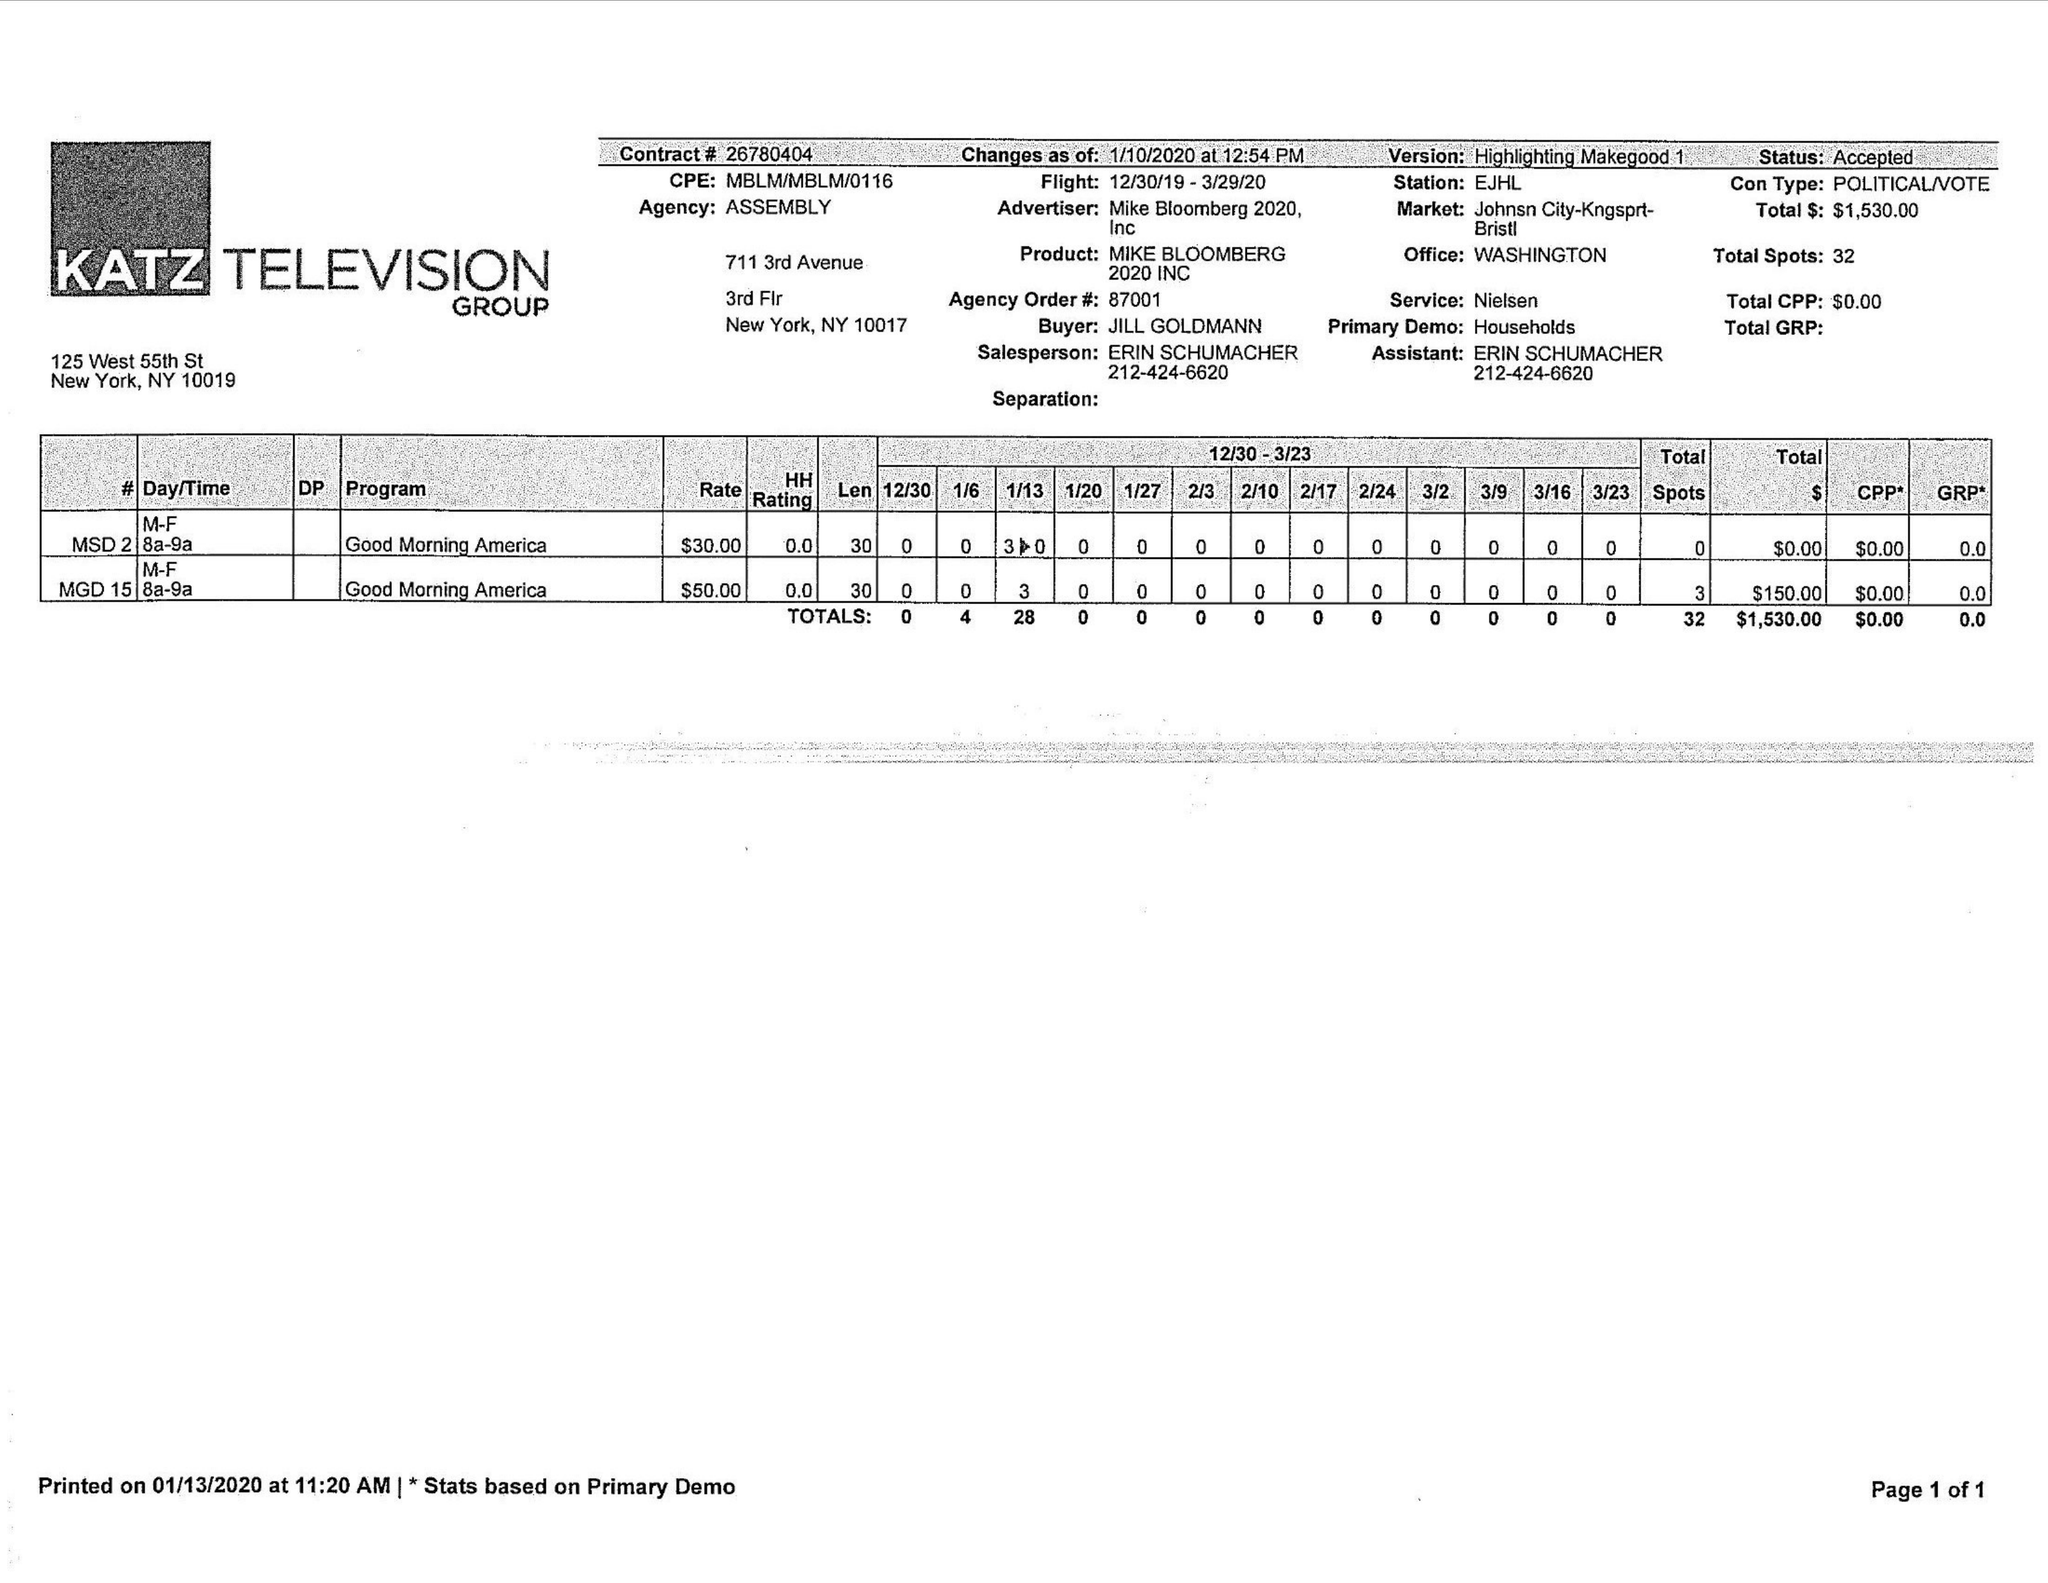What is the value for the flight_to?
Answer the question using a single word or phrase. 03/29/20 